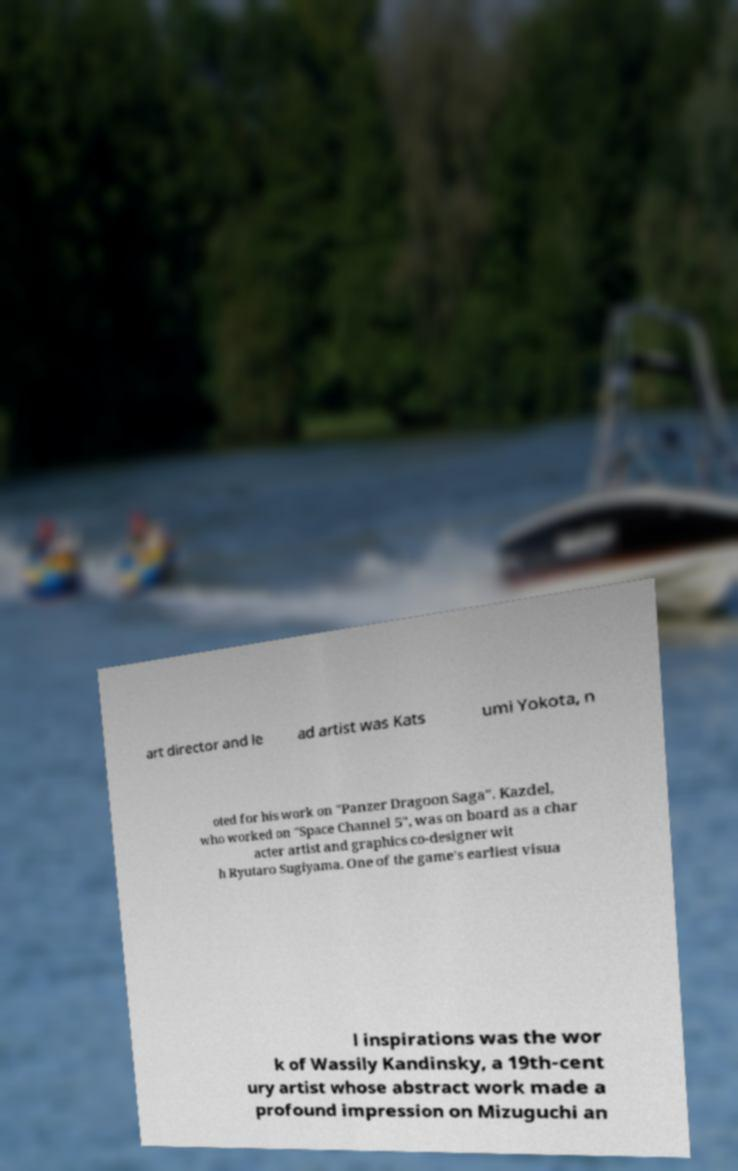Can you read and provide the text displayed in the image?This photo seems to have some interesting text. Can you extract and type it out for me? art director and le ad artist was Kats umi Yokota, n oted for his work on "Panzer Dragoon Saga". Kazdel, who worked on "Space Channel 5", was on board as a char acter artist and graphics co-designer wit h Ryutaro Sugiyama. One of the game's earliest visua l inspirations was the wor k of Wassily Kandinsky, a 19th-cent ury artist whose abstract work made a profound impression on Mizuguchi an 